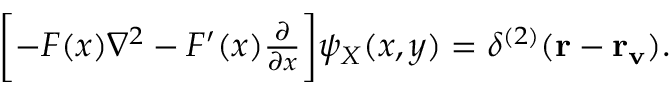Convert formula to latex. <formula><loc_0><loc_0><loc_500><loc_500>\begin{array} { r } { \left [ - F ( x ) \nabla ^ { 2 } - F ^ { \prime } ( x ) \frac { \partial } { \partial x } \right ] \psi _ { X } ( x , y ) = \delta ^ { ( 2 ) } ( { r } - { r _ { v } } ) . } \end{array}</formula> 